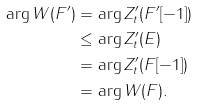Convert formula to latex. <formula><loc_0><loc_0><loc_500><loc_500>\arg W ( F ^ { \prime } ) & = \arg Z _ { t } ^ { \prime } ( F ^ { \prime } [ - 1 ] ) \\ & \leq \arg Z _ { t } ^ { \prime } ( E ) \\ & = \arg Z _ { t } ^ { \prime } ( F [ - 1 ] ) \\ & = \arg W ( F ) .</formula> 